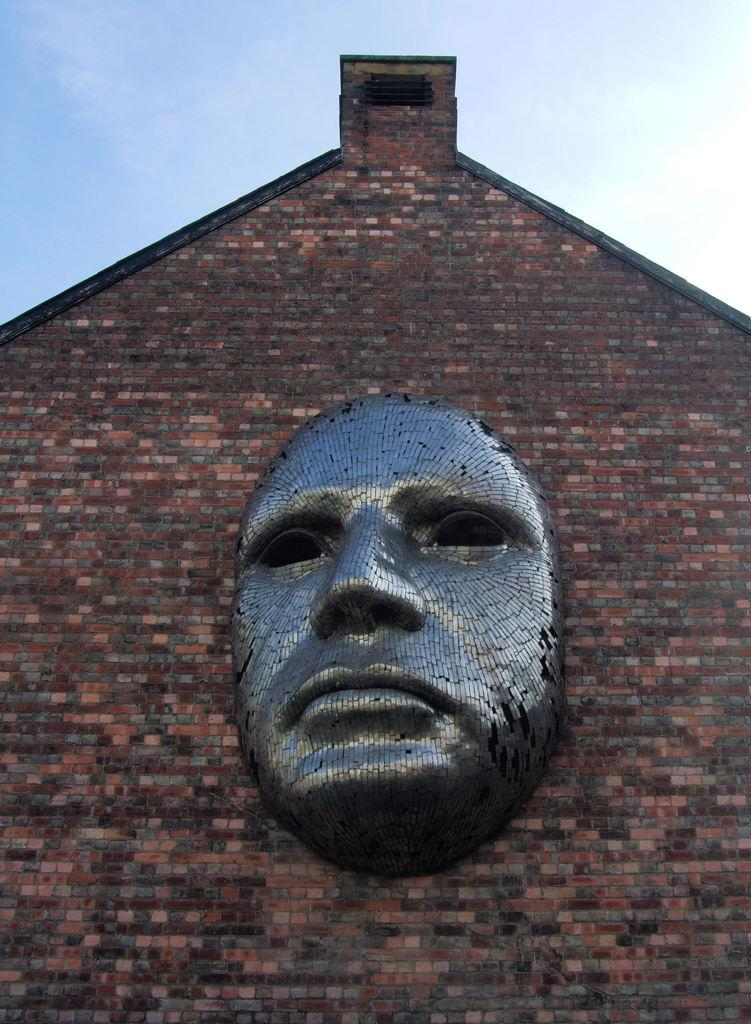What is depicted on the wall of the building in the image? There is a statue of a human face on the wall of the building. What material is the building made of? The building is made up of red bricks. What is the condition of the sky in the image? The sky is clear in the image. What type of plant is growing out of the statue's ear in the image? There is no plant growing out of the statue's ear in the image, as the statue is a human face on the wall of a building. 